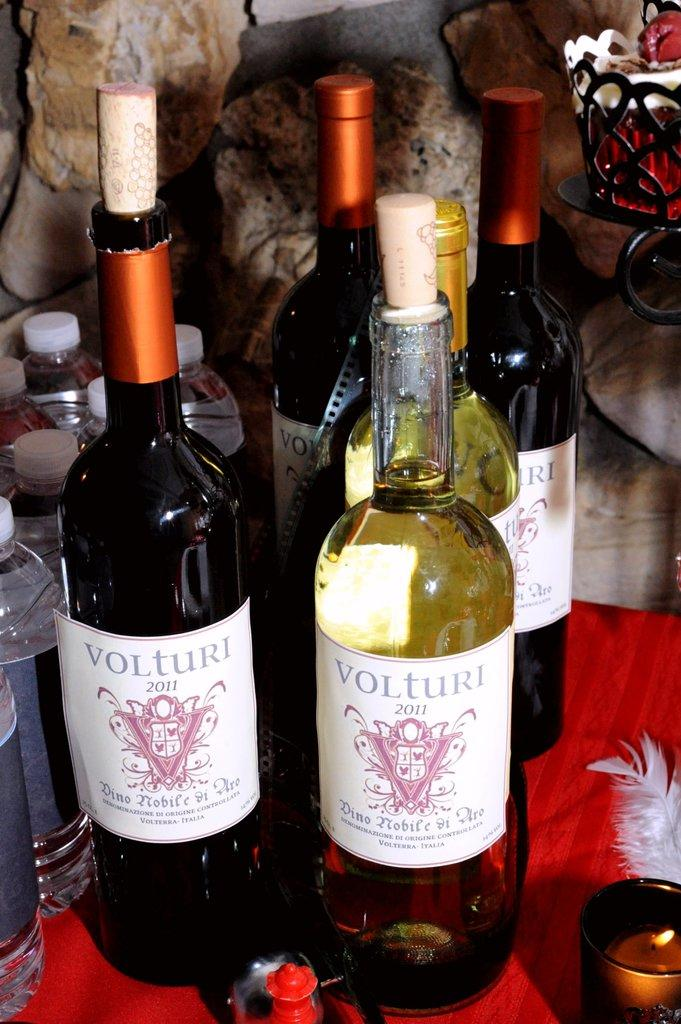What type of beverages are present on the table in the image? There are wine bottles on the table. Can you describe the background of the image? The background has some designing. What other type of beverage can be seen in the image? There are water bottles in the background. What type of pan is being used to cook in the image? There is no pan or cooking activity present in the image. How is the butter being used in the image? There is no butter present in the image. 